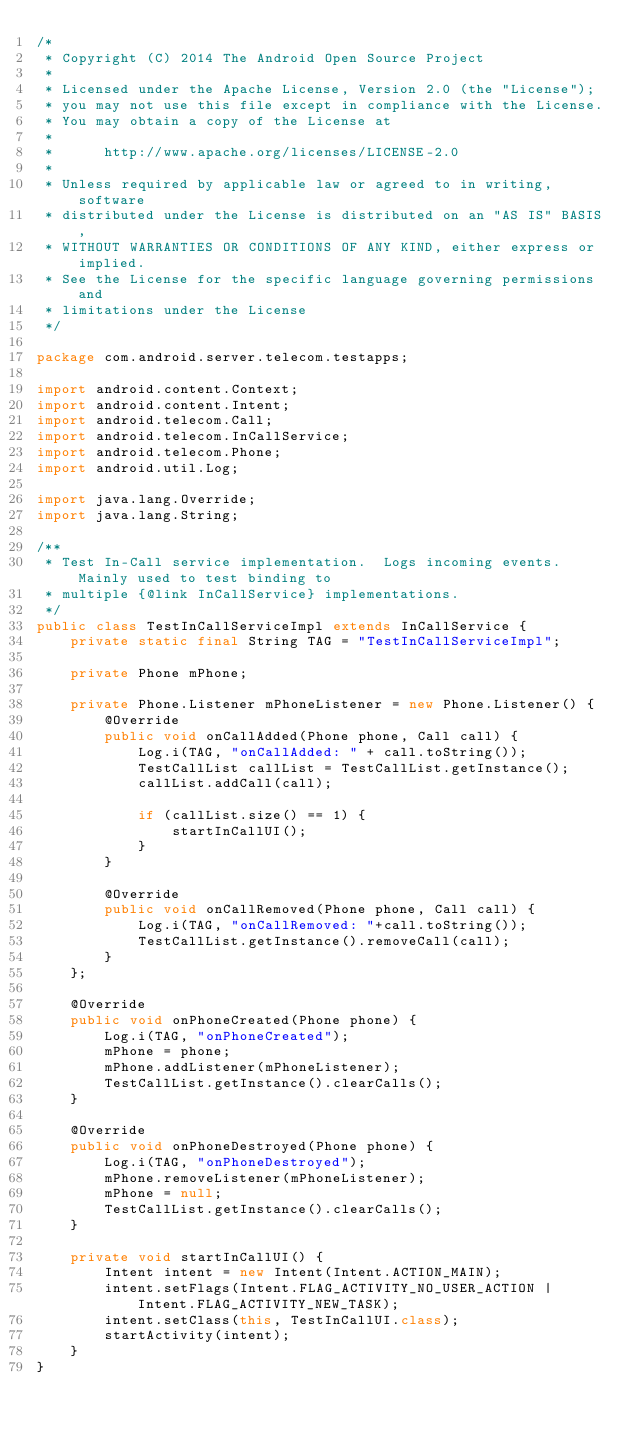Convert code to text. <code><loc_0><loc_0><loc_500><loc_500><_Java_>/*
 * Copyright (C) 2014 The Android Open Source Project
 *
 * Licensed under the Apache License, Version 2.0 (the "License");
 * you may not use this file except in compliance with the License.
 * You may obtain a copy of the License at
 *
 *      http://www.apache.org/licenses/LICENSE-2.0
 *
 * Unless required by applicable law or agreed to in writing, software
 * distributed under the License is distributed on an "AS IS" BASIS,
 * WITHOUT WARRANTIES OR CONDITIONS OF ANY KIND, either express or implied.
 * See the License for the specific language governing permissions and
 * limitations under the License
 */

package com.android.server.telecom.testapps;

import android.content.Context;
import android.content.Intent;
import android.telecom.Call;
import android.telecom.InCallService;
import android.telecom.Phone;
import android.util.Log;

import java.lang.Override;
import java.lang.String;

/**
 * Test In-Call service implementation.  Logs incoming events.  Mainly used to test binding to
 * multiple {@link InCallService} implementations.
 */
public class TestInCallServiceImpl extends InCallService {
    private static final String TAG = "TestInCallServiceImpl";

    private Phone mPhone;

    private Phone.Listener mPhoneListener = new Phone.Listener() {
        @Override
        public void onCallAdded(Phone phone, Call call) {
            Log.i(TAG, "onCallAdded: " + call.toString());
            TestCallList callList = TestCallList.getInstance();
            callList.addCall(call);

            if (callList.size() == 1) {
                startInCallUI();
            }
        }

        @Override
        public void onCallRemoved(Phone phone, Call call) {
            Log.i(TAG, "onCallRemoved: "+call.toString());
            TestCallList.getInstance().removeCall(call);
        }
    };

    @Override
    public void onPhoneCreated(Phone phone) {
        Log.i(TAG, "onPhoneCreated");
        mPhone = phone;
        mPhone.addListener(mPhoneListener);
        TestCallList.getInstance().clearCalls();
    }

    @Override
    public void onPhoneDestroyed(Phone phone) {
        Log.i(TAG, "onPhoneDestroyed");
        mPhone.removeListener(mPhoneListener);
        mPhone = null;
        TestCallList.getInstance().clearCalls();
    }

    private void startInCallUI() {
        Intent intent = new Intent(Intent.ACTION_MAIN);
        intent.setFlags(Intent.FLAG_ACTIVITY_NO_USER_ACTION | Intent.FLAG_ACTIVITY_NEW_TASK);
        intent.setClass(this, TestInCallUI.class);
        startActivity(intent);
    }
}
</code> 